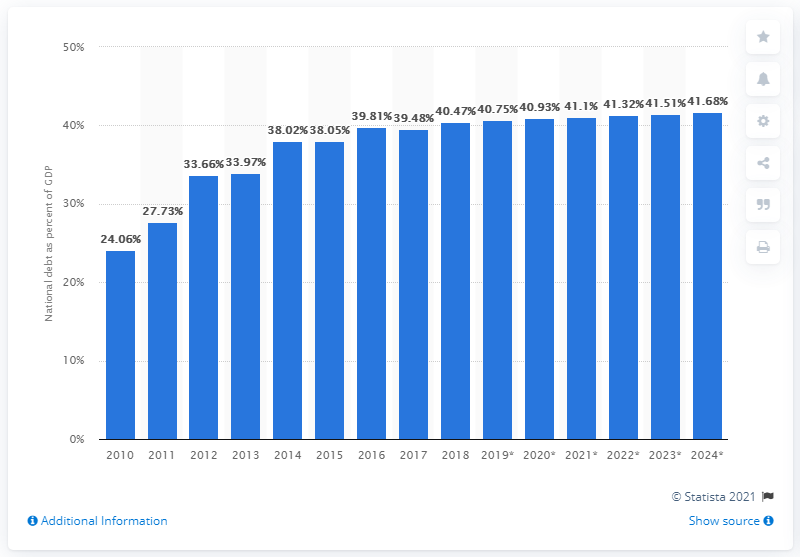Draw attention to some important aspects in this diagram. In 2018, the national debt of North Macedonia accounted for 40.75% of the country's Gross Domestic Product (GDP). 